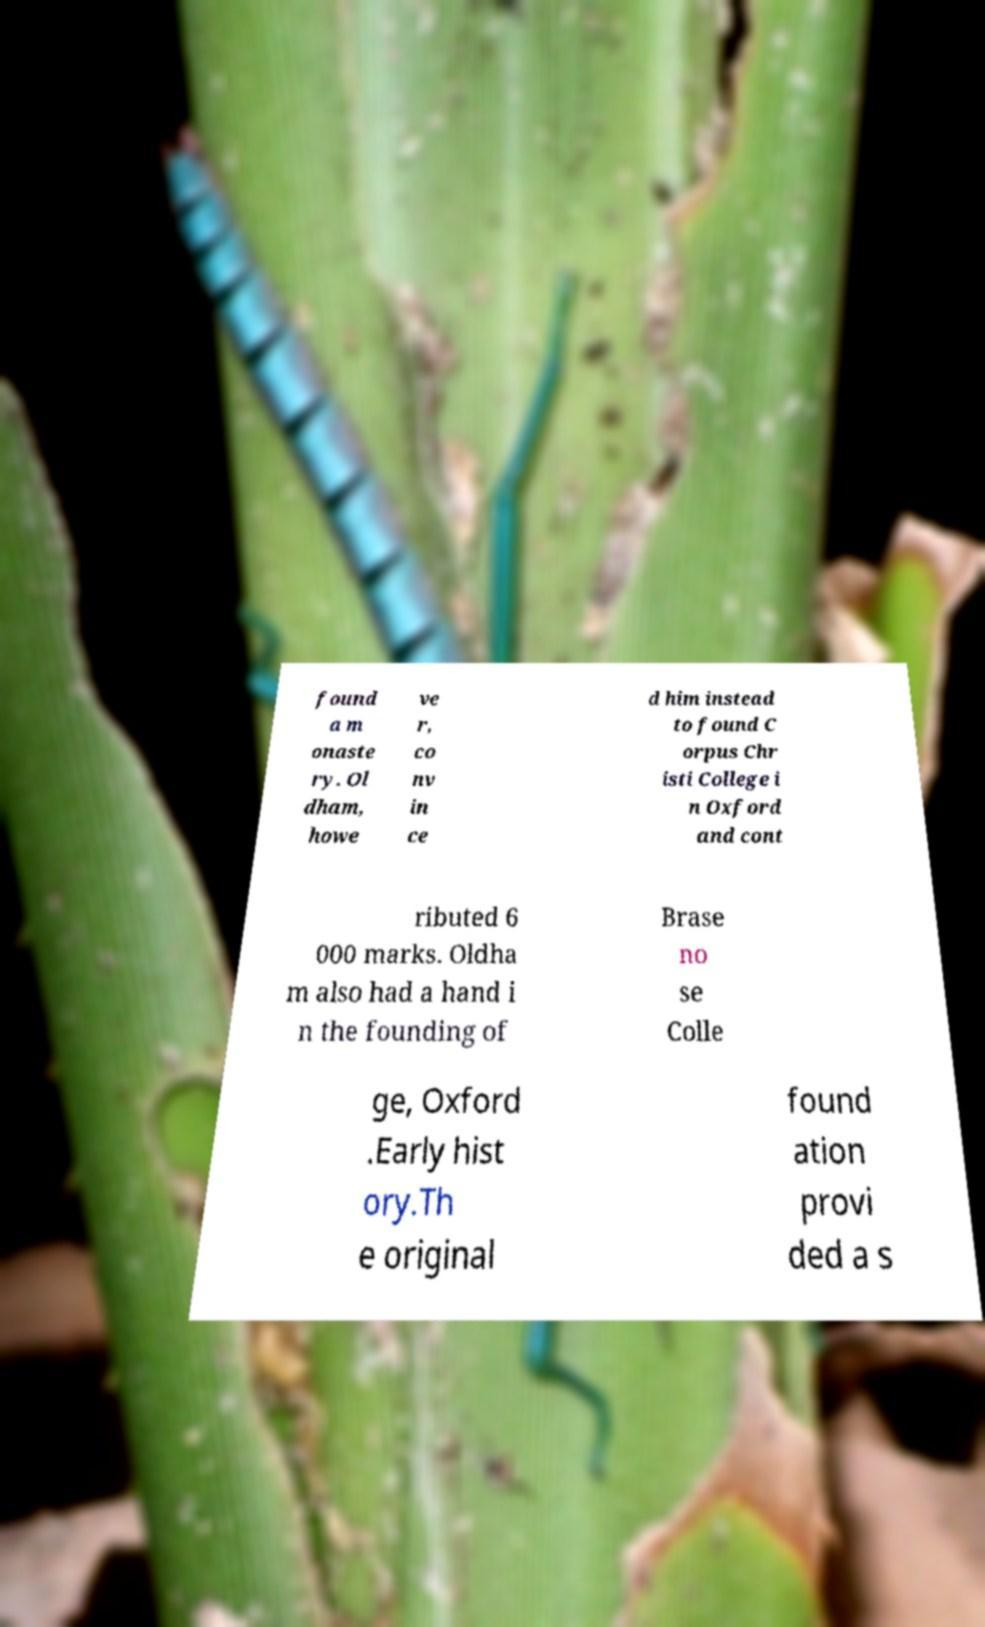For documentation purposes, I need the text within this image transcribed. Could you provide that? found a m onaste ry. Ol dham, howe ve r, co nv in ce d him instead to found C orpus Chr isti College i n Oxford and cont ributed 6 000 marks. Oldha m also had a hand i n the founding of Brase no se Colle ge, Oxford .Early hist ory.Th e original found ation provi ded a s 